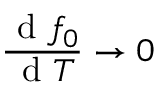Convert formula to latex. <formula><loc_0><loc_0><loc_500><loc_500>\frac { d f _ { 0 } } { d T } \rightarrow 0</formula> 